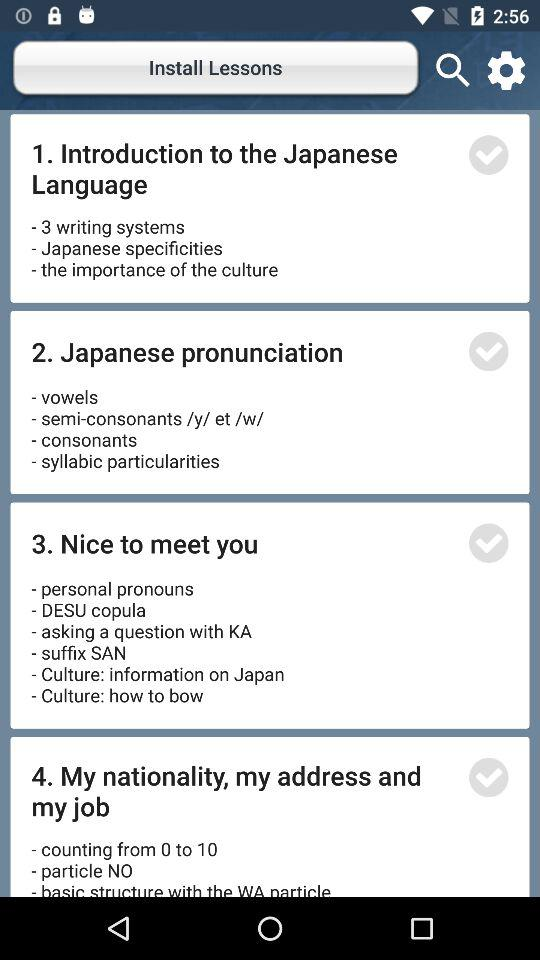What is the total number of lessons?
When the provided information is insufficient, respond with <no answer>. <no answer> 